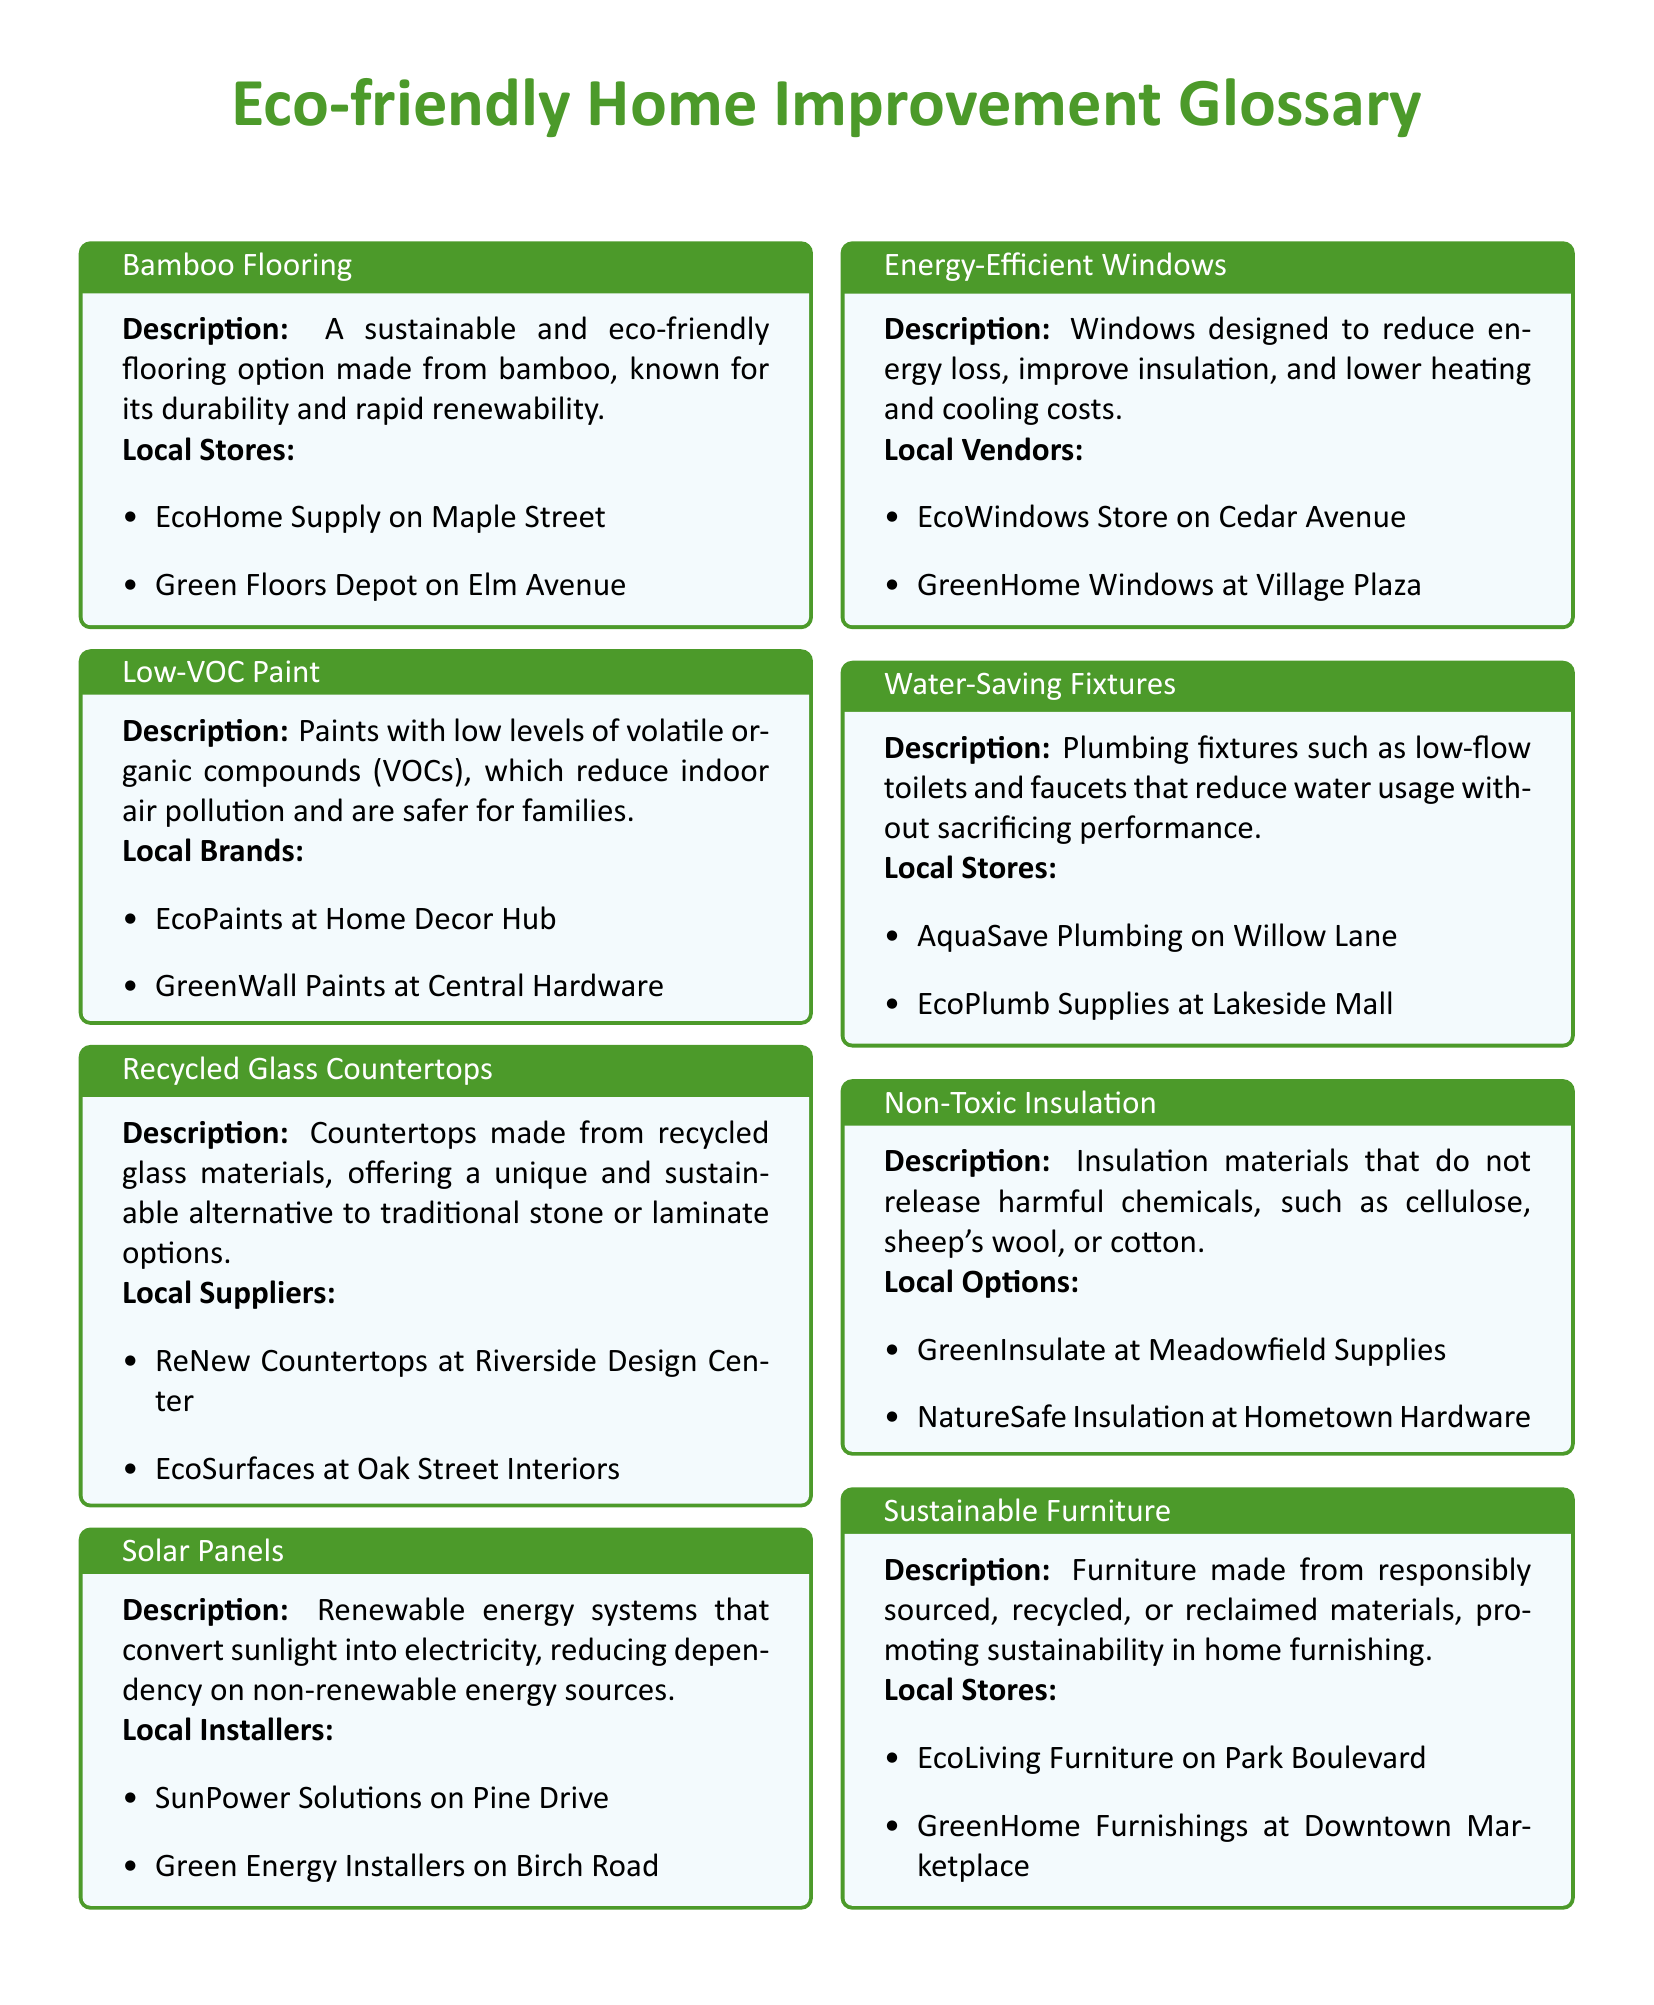What is bamboo flooring made from? Bamboo flooring is described as being made from bamboo, which is known for its durability and rapid renewability.
Answer: bamboo Which store sells low-VOC paint? The document lists EcoPaints at Home Decor Hub as a local brand selling low-VOC paint.
Answer: EcoPaints at Home Decor Hub What is recycled glass countertops made from? Recycled glass countertops are made from recycled glass materials, offering a sustainable alternative to traditional options.
Answer: recycled glass Name one local installer of solar panels. SunPower Solutions on Pine Drive is mentioned as a local installer of solar panels.
Answer: SunPower Solutions What type of fixtures do water-saving fixtures include? Water-saving fixtures include low-flow toilets and faucets that reduce water usage.
Answer: toilets and faucets What benefit do energy-efficient windows provide? Energy-efficient windows are designed to reduce energy loss, improve insulation, and lower heating and cooling costs.
Answer: reduce energy loss Where can you find sustainable furniture? The document mentions EcoLiving Furniture on Park Boulevard and GreenHome Furnishings at Downtown Marketplace as local stores for sustainable furniture.
Answer: EcoLiving Furniture on Park Boulevard What type of insulation is non-toxic insulation made from? Non-toxic insulation is made from materials that do not release harmful chemicals, such as cellulose, sheep's wool, or cotton.
Answer: cellulose, sheep's wool, or cotton Which color is used for the title of the glossary? The title uses the color leaf green as indicated in the document.
Answer: leaf green 